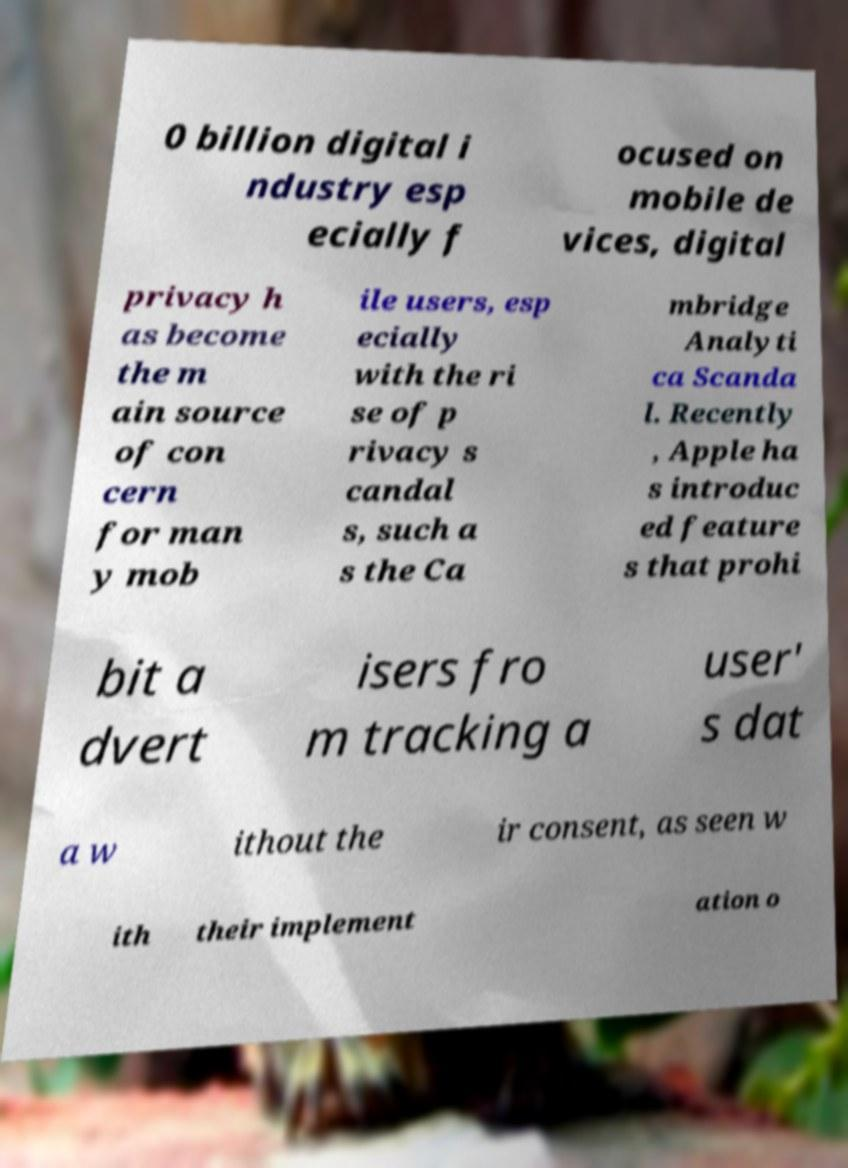Please identify and transcribe the text found in this image. 0 billion digital i ndustry esp ecially f ocused on mobile de vices, digital privacy h as become the m ain source of con cern for man y mob ile users, esp ecially with the ri se of p rivacy s candal s, such a s the Ca mbridge Analyti ca Scanda l. Recently , Apple ha s introduc ed feature s that prohi bit a dvert isers fro m tracking a user' s dat a w ithout the ir consent, as seen w ith their implement ation o 